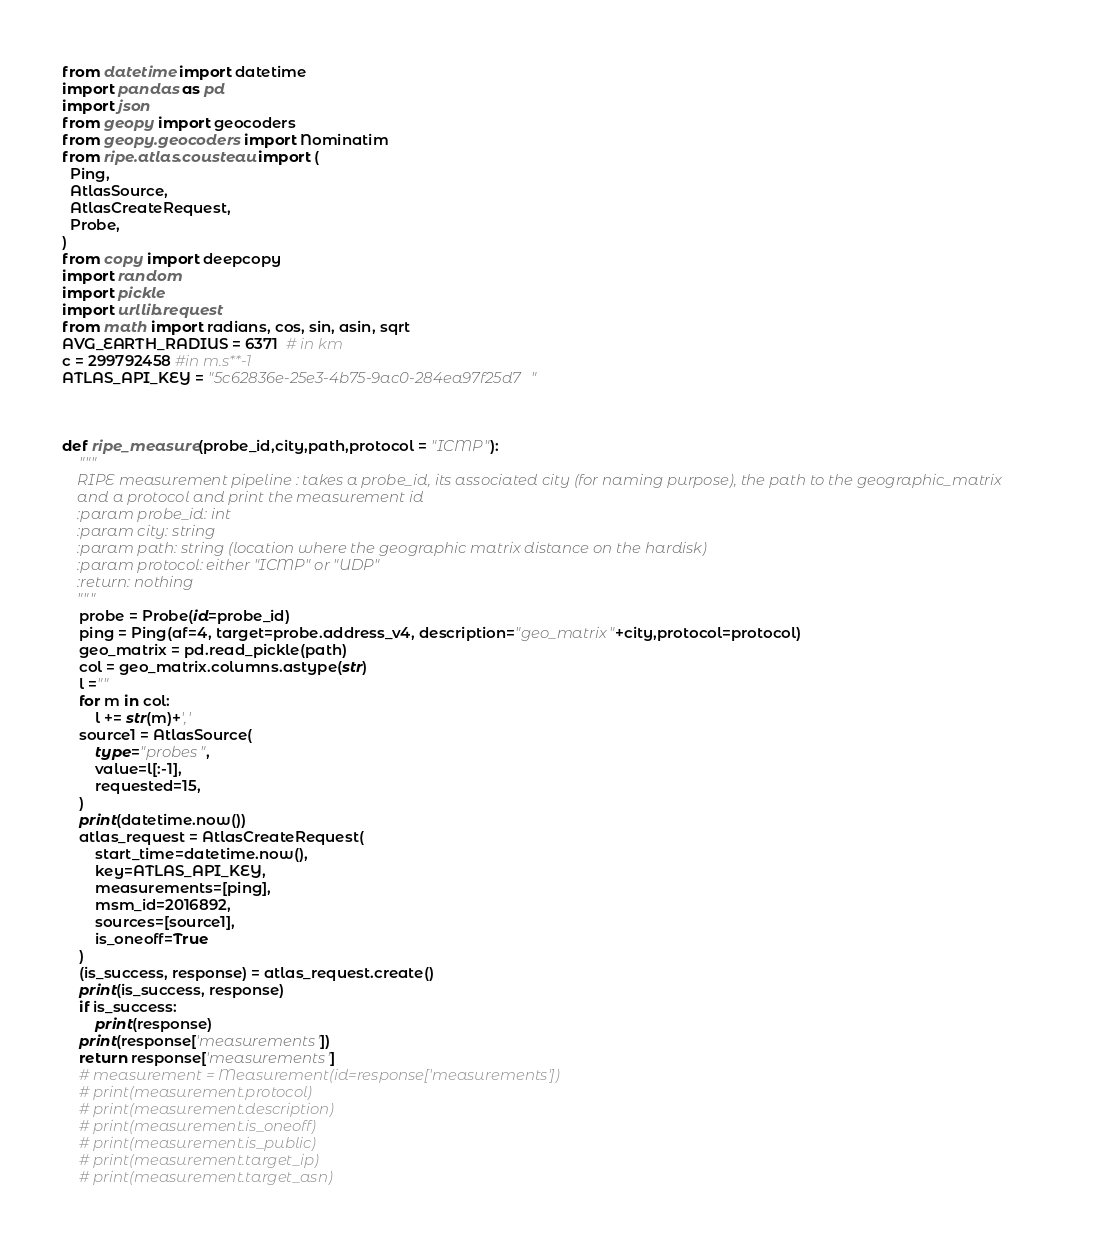<code> <loc_0><loc_0><loc_500><loc_500><_Python_>from datetime import datetime
import pandas as pd
import json
from geopy import geocoders
from geopy.geocoders import Nominatim
from ripe.atlas.cousteau import (
  Ping,
  AtlasSource,
  AtlasCreateRequest,
  Probe,
)
from copy import deepcopy
import random
import pickle
import urllib.request
from math import radians, cos, sin, asin, sqrt
AVG_EARTH_RADIUS = 6371  # in km
c = 299792458 #in m.s**-1
ATLAS_API_KEY = "5c62836e-25e3-4b75-9ac0-284ea97f25d7"



def ripe_measure(probe_id,city,path,protocol = "ICMP"):
    """
    RIPE measurement pipeline : takes a probe_id, its associated city (for naming purpose), the path to the geographic_matrix
    and a protocol and print the measurement id
    :param probe_id: int
    :param city: string
    :param path: string (location where the geographic matrix distance on the hardisk)
    :param protocol: either "ICMP" or "UDP"
    :return: nothing
    """
    probe = Probe(id=probe_id)
    ping = Ping(af=4, target=probe.address_v4, description="geo_matrix"+city,protocol=protocol)
    geo_matrix = pd.read_pickle(path)
    col = geo_matrix.columns.astype(str)
    l =""
    for m in col:
        l += str(m)+','
    source1 = AtlasSource(
        type="probes",
        value=l[:-1],
        requested=15,
    )
    print(datetime.now())
    atlas_request = AtlasCreateRequest(
        start_time=datetime.now(),
        key=ATLAS_API_KEY,
        measurements=[ping],
        msm_id=2016892,
        sources=[source1],
        is_oneoff=True
    )
    (is_success, response) = atlas_request.create()
    print(is_success, response)
    if is_success:
        print(response)
    print(response['measurements'])
    return response['measurements']
    # measurement = Measurement(id=response['measurements'])
    # print(measurement.protocol)
    # print(measurement.description)
    # print(measurement.is_oneoff)
    # print(measurement.is_public)
    # print(measurement.target_ip)
    # print(measurement.target_asn)</code> 